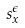<formula> <loc_0><loc_0><loc_500><loc_500>s _ { x } ^ { \epsilon }</formula> 